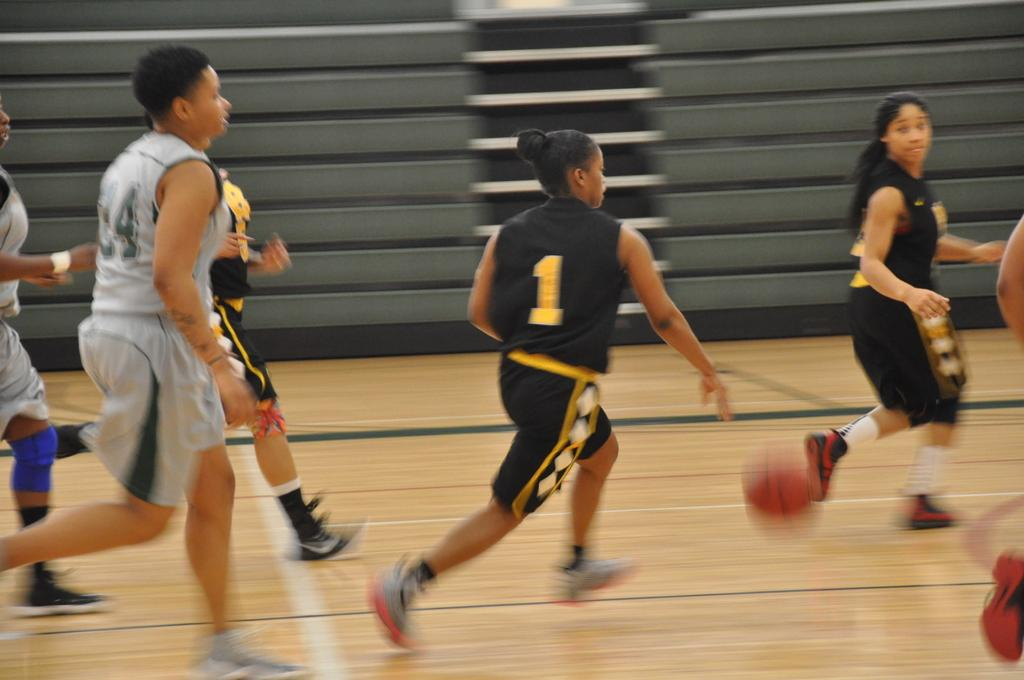Who or what can be seen in the image? There are people in the image. What are the people wearing? The people are wearing t-shirts and shorts. What direction are the people moving in? The people are running towards the right side. What activity might the people be engaged in? It appears that they are playing football. What can be seen in the background of the image? There are stairs in the background of the image. What flavor of mark can be seen on the t-shirts of the people in the image? There is no mark or any indication of a specific flavor on the t-shirts of the people in the image. 